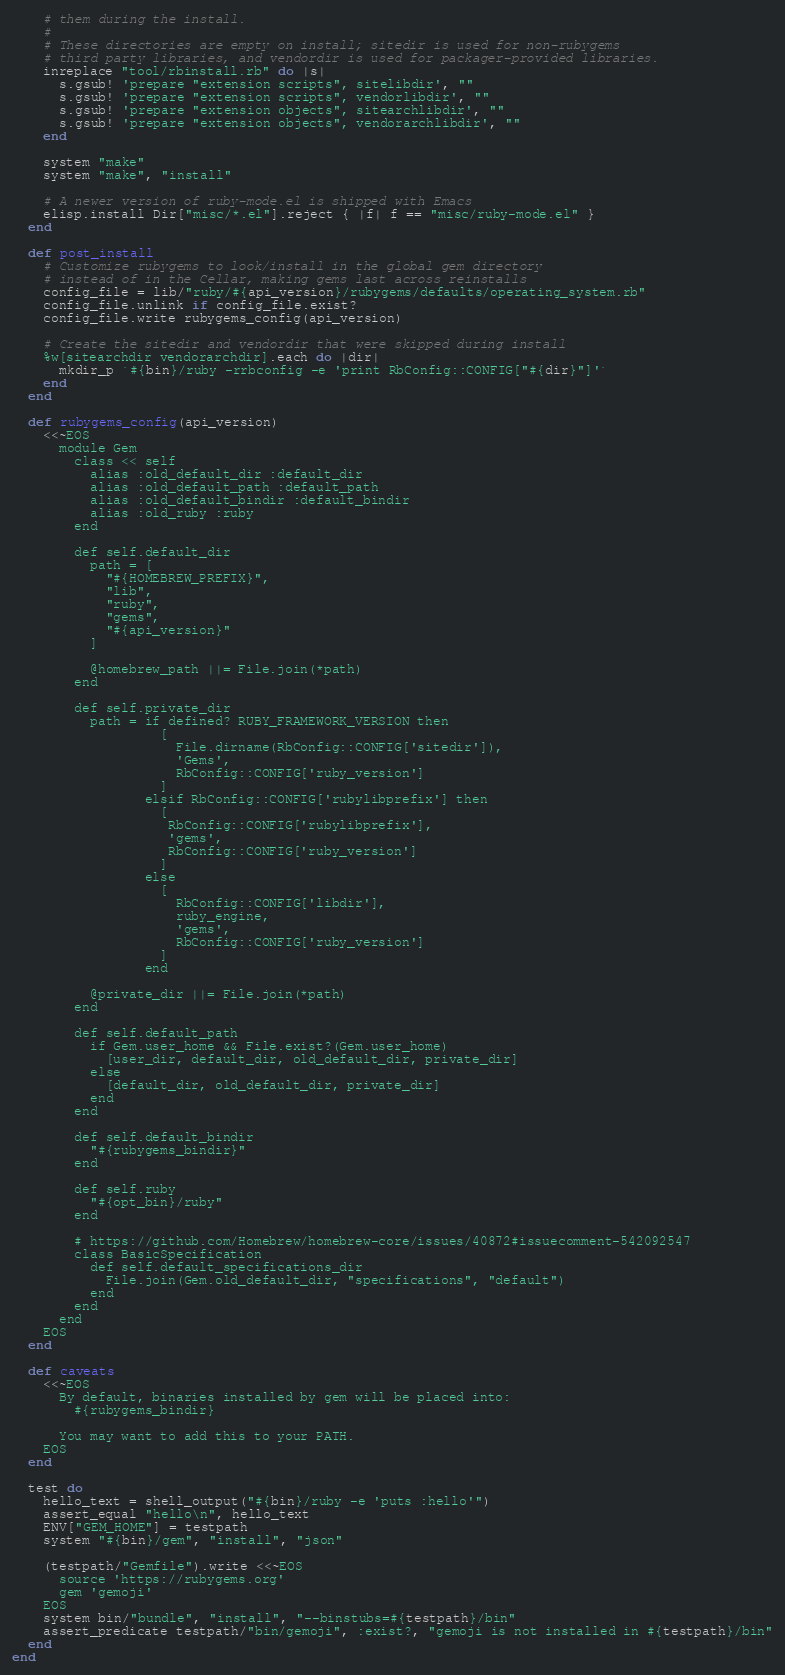Convert code to text. <code><loc_0><loc_0><loc_500><loc_500><_Ruby_>    # them during the install.
    #
    # These directories are empty on install; sitedir is used for non-rubygems
    # third party libraries, and vendordir is used for packager-provided libraries.
    inreplace "tool/rbinstall.rb" do |s|
      s.gsub! 'prepare "extension scripts", sitelibdir', ""
      s.gsub! 'prepare "extension scripts", vendorlibdir', ""
      s.gsub! 'prepare "extension objects", sitearchlibdir', ""
      s.gsub! 'prepare "extension objects", vendorarchlibdir', ""
    end

    system "make"
    system "make", "install"

    # A newer version of ruby-mode.el is shipped with Emacs
    elisp.install Dir["misc/*.el"].reject { |f| f == "misc/ruby-mode.el" }
  end

  def post_install
    # Customize rubygems to look/install in the global gem directory
    # instead of in the Cellar, making gems last across reinstalls
    config_file = lib/"ruby/#{api_version}/rubygems/defaults/operating_system.rb"
    config_file.unlink if config_file.exist?
    config_file.write rubygems_config(api_version)

    # Create the sitedir and vendordir that were skipped during install
    %w[sitearchdir vendorarchdir].each do |dir|
      mkdir_p `#{bin}/ruby -rrbconfig -e 'print RbConfig::CONFIG["#{dir}"]'`
    end
  end

  def rubygems_config(api_version)
    <<~EOS
      module Gem
        class << self
          alias :old_default_dir :default_dir
          alias :old_default_path :default_path
          alias :old_default_bindir :default_bindir
          alias :old_ruby :ruby
        end

        def self.default_dir
          path = [
            "#{HOMEBREW_PREFIX}",
            "lib",
            "ruby",
            "gems",
            "#{api_version}"
          ]

          @homebrew_path ||= File.join(*path)
        end

        def self.private_dir
          path = if defined? RUBY_FRAMEWORK_VERSION then
                   [
                     File.dirname(RbConfig::CONFIG['sitedir']),
                     'Gems',
                     RbConfig::CONFIG['ruby_version']
                   ]
                 elsif RbConfig::CONFIG['rubylibprefix'] then
                   [
                    RbConfig::CONFIG['rubylibprefix'],
                    'gems',
                    RbConfig::CONFIG['ruby_version']
                   ]
                 else
                   [
                     RbConfig::CONFIG['libdir'],
                     ruby_engine,
                     'gems',
                     RbConfig::CONFIG['ruby_version']
                   ]
                 end

          @private_dir ||= File.join(*path)
        end

        def self.default_path
          if Gem.user_home && File.exist?(Gem.user_home)
            [user_dir, default_dir, old_default_dir, private_dir]
          else
            [default_dir, old_default_dir, private_dir]
          end
        end

        def self.default_bindir
          "#{rubygems_bindir}"
        end

        def self.ruby
          "#{opt_bin}/ruby"
        end

        # https://github.com/Homebrew/homebrew-core/issues/40872#issuecomment-542092547
        class BasicSpecification
          def self.default_specifications_dir
            File.join(Gem.old_default_dir, "specifications", "default")
          end
        end
      end
    EOS
  end

  def caveats
    <<~EOS
      By default, binaries installed by gem will be placed into:
        #{rubygems_bindir}

      You may want to add this to your PATH.
    EOS
  end

  test do
    hello_text = shell_output("#{bin}/ruby -e 'puts :hello'")
    assert_equal "hello\n", hello_text
    ENV["GEM_HOME"] = testpath
    system "#{bin}/gem", "install", "json"

    (testpath/"Gemfile").write <<~EOS
      source 'https://rubygems.org'
      gem 'gemoji'
    EOS
    system bin/"bundle", "install", "--binstubs=#{testpath}/bin"
    assert_predicate testpath/"bin/gemoji", :exist?, "gemoji is not installed in #{testpath}/bin"
  end
end
</code> 